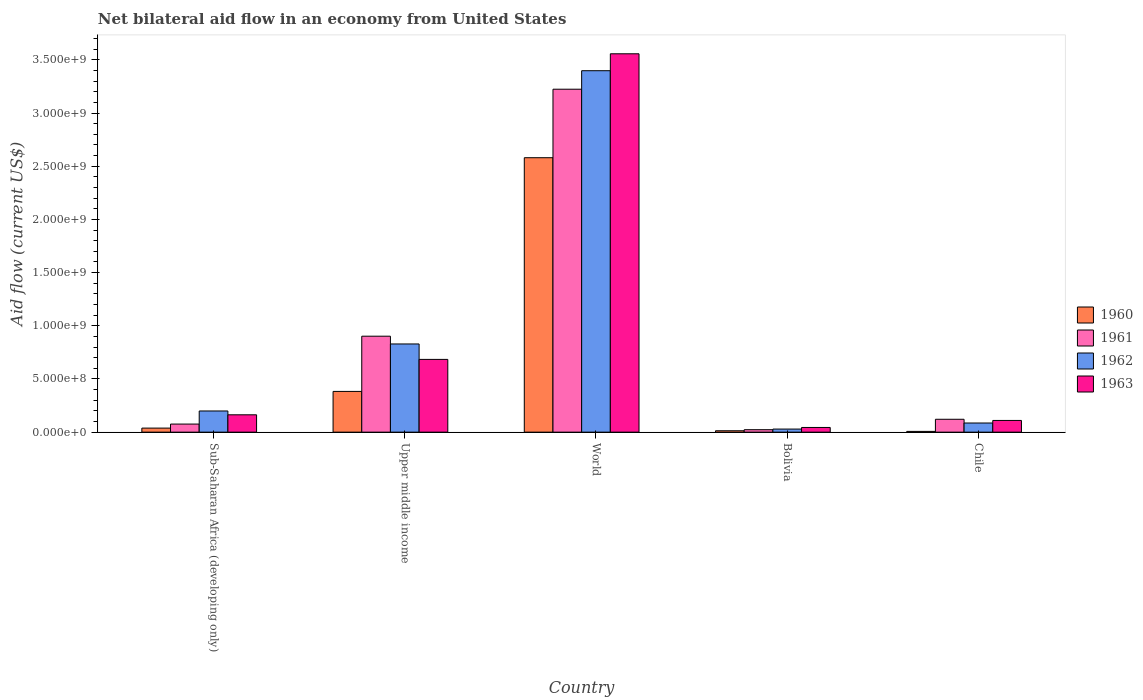How many groups of bars are there?
Keep it short and to the point. 5. Are the number of bars on each tick of the X-axis equal?
Provide a short and direct response. Yes. How many bars are there on the 1st tick from the right?
Provide a short and direct response. 4. What is the label of the 2nd group of bars from the left?
Provide a succinct answer. Upper middle income. What is the net bilateral aid flow in 1961 in Upper middle income?
Provide a short and direct response. 9.02e+08. Across all countries, what is the maximum net bilateral aid flow in 1960?
Provide a succinct answer. 2.58e+09. Across all countries, what is the minimum net bilateral aid flow in 1962?
Provide a succinct answer. 2.90e+07. In which country was the net bilateral aid flow in 1962 maximum?
Offer a very short reply. World. What is the total net bilateral aid flow in 1960 in the graph?
Your response must be concise. 3.02e+09. What is the difference between the net bilateral aid flow in 1963 in Bolivia and that in Upper middle income?
Ensure brevity in your answer.  -6.40e+08. What is the difference between the net bilateral aid flow in 1961 in Bolivia and the net bilateral aid flow in 1962 in Sub-Saharan Africa (developing only)?
Ensure brevity in your answer.  -1.76e+08. What is the average net bilateral aid flow in 1963 per country?
Make the answer very short. 9.12e+08. What is the difference between the net bilateral aid flow of/in 1960 and net bilateral aid flow of/in 1961 in World?
Your answer should be compact. -6.44e+08. What is the ratio of the net bilateral aid flow in 1963 in Sub-Saharan Africa (developing only) to that in Upper middle income?
Make the answer very short. 0.24. Is the net bilateral aid flow in 1961 in Sub-Saharan Africa (developing only) less than that in World?
Give a very brief answer. Yes. What is the difference between the highest and the second highest net bilateral aid flow in 1960?
Provide a short and direct response. 2.54e+09. What is the difference between the highest and the lowest net bilateral aid flow in 1962?
Your response must be concise. 3.37e+09. Is it the case that in every country, the sum of the net bilateral aid flow in 1960 and net bilateral aid flow in 1962 is greater than the sum of net bilateral aid flow in 1961 and net bilateral aid flow in 1963?
Give a very brief answer. No. What does the 4th bar from the left in Chile represents?
Offer a very short reply. 1963. Are all the bars in the graph horizontal?
Provide a short and direct response. No. How many countries are there in the graph?
Ensure brevity in your answer.  5. Are the values on the major ticks of Y-axis written in scientific E-notation?
Ensure brevity in your answer.  Yes. Does the graph contain any zero values?
Provide a succinct answer. No. How many legend labels are there?
Offer a very short reply. 4. What is the title of the graph?
Provide a succinct answer. Net bilateral aid flow in an economy from United States. What is the label or title of the X-axis?
Give a very brief answer. Country. What is the Aid flow (current US$) in 1960 in Sub-Saharan Africa (developing only)?
Ensure brevity in your answer.  3.80e+07. What is the Aid flow (current US$) of 1961 in Sub-Saharan Africa (developing only)?
Keep it short and to the point. 7.60e+07. What is the Aid flow (current US$) of 1962 in Sub-Saharan Africa (developing only)?
Provide a short and direct response. 1.99e+08. What is the Aid flow (current US$) in 1963 in Sub-Saharan Africa (developing only)?
Ensure brevity in your answer.  1.63e+08. What is the Aid flow (current US$) in 1960 in Upper middle income?
Provide a succinct answer. 3.83e+08. What is the Aid flow (current US$) of 1961 in Upper middle income?
Your answer should be compact. 9.02e+08. What is the Aid flow (current US$) in 1962 in Upper middle income?
Ensure brevity in your answer.  8.29e+08. What is the Aid flow (current US$) of 1963 in Upper middle income?
Offer a very short reply. 6.84e+08. What is the Aid flow (current US$) in 1960 in World?
Ensure brevity in your answer.  2.58e+09. What is the Aid flow (current US$) of 1961 in World?
Your answer should be compact. 3.22e+09. What is the Aid flow (current US$) of 1962 in World?
Your response must be concise. 3.40e+09. What is the Aid flow (current US$) of 1963 in World?
Your answer should be compact. 3.56e+09. What is the Aid flow (current US$) of 1960 in Bolivia?
Provide a short and direct response. 1.30e+07. What is the Aid flow (current US$) of 1961 in Bolivia?
Your answer should be very brief. 2.30e+07. What is the Aid flow (current US$) of 1962 in Bolivia?
Provide a succinct answer. 2.90e+07. What is the Aid flow (current US$) in 1963 in Bolivia?
Offer a terse response. 4.40e+07. What is the Aid flow (current US$) in 1961 in Chile?
Your answer should be compact. 1.21e+08. What is the Aid flow (current US$) in 1962 in Chile?
Offer a terse response. 8.60e+07. What is the Aid flow (current US$) of 1963 in Chile?
Offer a very short reply. 1.10e+08. Across all countries, what is the maximum Aid flow (current US$) in 1960?
Provide a short and direct response. 2.58e+09. Across all countries, what is the maximum Aid flow (current US$) of 1961?
Ensure brevity in your answer.  3.22e+09. Across all countries, what is the maximum Aid flow (current US$) in 1962?
Provide a short and direct response. 3.40e+09. Across all countries, what is the maximum Aid flow (current US$) in 1963?
Your answer should be very brief. 3.56e+09. Across all countries, what is the minimum Aid flow (current US$) of 1961?
Keep it short and to the point. 2.30e+07. Across all countries, what is the minimum Aid flow (current US$) in 1962?
Your response must be concise. 2.90e+07. Across all countries, what is the minimum Aid flow (current US$) in 1963?
Keep it short and to the point. 4.40e+07. What is the total Aid flow (current US$) in 1960 in the graph?
Your response must be concise. 3.02e+09. What is the total Aid flow (current US$) in 1961 in the graph?
Your answer should be very brief. 4.35e+09. What is the total Aid flow (current US$) of 1962 in the graph?
Your answer should be very brief. 4.54e+09. What is the total Aid flow (current US$) of 1963 in the graph?
Make the answer very short. 4.56e+09. What is the difference between the Aid flow (current US$) of 1960 in Sub-Saharan Africa (developing only) and that in Upper middle income?
Offer a terse response. -3.45e+08. What is the difference between the Aid flow (current US$) of 1961 in Sub-Saharan Africa (developing only) and that in Upper middle income?
Provide a succinct answer. -8.26e+08. What is the difference between the Aid flow (current US$) of 1962 in Sub-Saharan Africa (developing only) and that in Upper middle income?
Keep it short and to the point. -6.30e+08. What is the difference between the Aid flow (current US$) in 1963 in Sub-Saharan Africa (developing only) and that in Upper middle income?
Make the answer very short. -5.21e+08. What is the difference between the Aid flow (current US$) in 1960 in Sub-Saharan Africa (developing only) and that in World?
Your response must be concise. -2.54e+09. What is the difference between the Aid flow (current US$) in 1961 in Sub-Saharan Africa (developing only) and that in World?
Your response must be concise. -3.15e+09. What is the difference between the Aid flow (current US$) in 1962 in Sub-Saharan Africa (developing only) and that in World?
Offer a very short reply. -3.20e+09. What is the difference between the Aid flow (current US$) of 1963 in Sub-Saharan Africa (developing only) and that in World?
Ensure brevity in your answer.  -3.39e+09. What is the difference between the Aid flow (current US$) of 1960 in Sub-Saharan Africa (developing only) and that in Bolivia?
Provide a succinct answer. 2.50e+07. What is the difference between the Aid flow (current US$) in 1961 in Sub-Saharan Africa (developing only) and that in Bolivia?
Ensure brevity in your answer.  5.30e+07. What is the difference between the Aid flow (current US$) of 1962 in Sub-Saharan Africa (developing only) and that in Bolivia?
Provide a short and direct response. 1.70e+08. What is the difference between the Aid flow (current US$) of 1963 in Sub-Saharan Africa (developing only) and that in Bolivia?
Make the answer very short. 1.19e+08. What is the difference between the Aid flow (current US$) of 1960 in Sub-Saharan Africa (developing only) and that in Chile?
Offer a very short reply. 3.10e+07. What is the difference between the Aid flow (current US$) in 1961 in Sub-Saharan Africa (developing only) and that in Chile?
Give a very brief answer. -4.50e+07. What is the difference between the Aid flow (current US$) of 1962 in Sub-Saharan Africa (developing only) and that in Chile?
Your answer should be compact. 1.13e+08. What is the difference between the Aid flow (current US$) of 1963 in Sub-Saharan Africa (developing only) and that in Chile?
Give a very brief answer. 5.30e+07. What is the difference between the Aid flow (current US$) of 1960 in Upper middle income and that in World?
Give a very brief answer. -2.20e+09. What is the difference between the Aid flow (current US$) in 1961 in Upper middle income and that in World?
Offer a very short reply. -2.32e+09. What is the difference between the Aid flow (current US$) in 1962 in Upper middle income and that in World?
Your response must be concise. -2.57e+09. What is the difference between the Aid flow (current US$) in 1963 in Upper middle income and that in World?
Your response must be concise. -2.87e+09. What is the difference between the Aid flow (current US$) of 1960 in Upper middle income and that in Bolivia?
Offer a terse response. 3.70e+08. What is the difference between the Aid flow (current US$) in 1961 in Upper middle income and that in Bolivia?
Your response must be concise. 8.79e+08. What is the difference between the Aid flow (current US$) in 1962 in Upper middle income and that in Bolivia?
Offer a terse response. 8.00e+08. What is the difference between the Aid flow (current US$) of 1963 in Upper middle income and that in Bolivia?
Your answer should be very brief. 6.40e+08. What is the difference between the Aid flow (current US$) in 1960 in Upper middle income and that in Chile?
Make the answer very short. 3.76e+08. What is the difference between the Aid flow (current US$) of 1961 in Upper middle income and that in Chile?
Provide a succinct answer. 7.81e+08. What is the difference between the Aid flow (current US$) in 1962 in Upper middle income and that in Chile?
Offer a very short reply. 7.43e+08. What is the difference between the Aid flow (current US$) of 1963 in Upper middle income and that in Chile?
Give a very brief answer. 5.74e+08. What is the difference between the Aid flow (current US$) of 1960 in World and that in Bolivia?
Provide a succinct answer. 2.57e+09. What is the difference between the Aid flow (current US$) of 1961 in World and that in Bolivia?
Give a very brief answer. 3.20e+09. What is the difference between the Aid flow (current US$) in 1962 in World and that in Bolivia?
Make the answer very short. 3.37e+09. What is the difference between the Aid flow (current US$) of 1963 in World and that in Bolivia?
Ensure brevity in your answer.  3.51e+09. What is the difference between the Aid flow (current US$) of 1960 in World and that in Chile?
Your answer should be compact. 2.57e+09. What is the difference between the Aid flow (current US$) in 1961 in World and that in Chile?
Keep it short and to the point. 3.10e+09. What is the difference between the Aid flow (current US$) in 1962 in World and that in Chile?
Provide a short and direct response. 3.31e+09. What is the difference between the Aid flow (current US$) of 1963 in World and that in Chile?
Make the answer very short. 3.45e+09. What is the difference between the Aid flow (current US$) of 1961 in Bolivia and that in Chile?
Your response must be concise. -9.80e+07. What is the difference between the Aid flow (current US$) in 1962 in Bolivia and that in Chile?
Ensure brevity in your answer.  -5.70e+07. What is the difference between the Aid flow (current US$) in 1963 in Bolivia and that in Chile?
Offer a very short reply. -6.60e+07. What is the difference between the Aid flow (current US$) in 1960 in Sub-Saharan Africa (developing only) and the Aid flow (current US$) in 1961 in Upper middle income?
Your response must be concise. -8.64e+08. What is the difference between the Aid flow (current US$) of 1960 in Sub-Saharan Africa (developing only) and the Aid flow (current US$) of 1962 in Upper middle income?
Your response must be concise. -7.91e+08. What is the difference between the Aid flow (current US$) in 1960 in Sub-Saharan Africa (developing only) and the Aid flow (current US$) in 1963 in Upper middle income?
Your answer should be very brief. -6.46e+08. What is the difference between the Aid flow (current US$) in 1961 in Sub-Saharan Africa (developing only) and the Aid flow (current US$) in 1962 in Upper middle income?
Your answer should be compact. -7.53e+08. What is the difference between the Aid flow (current US$) of 1961 in Sub-Saharan Africa (developing only) and the Aid flow (current US$) of 1963 in Upper middle income?
Offer a very short reply. -6.08e+08. What is the difference between the Aid flow (current US$) of 1962 in Sub-Saharan Africa (developing only) and the Aid flow (current US$) of 1963 in Upper middle income?
Offer a terse response. -4.85e+08. What is the difference between the Aid flow (current US$) of 1960 in Sub-Saharan Africa (developing only) and the Aid flow (current US$) of 1961 in World?
Keep it short and to the point. -3.19e+09. What is the difference between the Aid flow (current US$) of 1960 in Sub-Saharan Africa (developing only) and the Aid flow (current US$) of 1962 in World?
Your answer should be compact. -3.36e+09. What is the difference between the Aid flow (current US$) in 1960 in Sub-Saharan Africa (developing only) and the Aid flow (current US$) in 1963 in World?
Your answer should be very brief. -3.52e+09. What is the difference between the Aid flow (current US$) in 1961 in Sub-Saharan Africa (developing only) and the Aid flow (current US$) in 1962 in World?
Provide a short and direct response. -3.32e+09. What is the difference between the Aid flow (current US$) of 1961 in Sub-Saharan Africa (developing only) and the Aid flow (current US$) of 1963 in World?
Offer a terse response. -3.48e+09. What is the difference between the Aid flow (current US$) in 1962 in Sub-Saharan Africa (developing only) and the Aid flow (current US$) in 1963 in World?
Ensure brevity in your answer.  -3.36e+09. What is the difference between the Aid flow (current US$) of 1960 in Sub-Saharan Africa (developing only) and the Aid flow (current US$) of 1961 in Bolivia?
Your answer should be compact. 1.50e+07. What is the difference between the Aid flow (current US$) in 1960 in Sub-Saharan Africa (developing only) and the Aid flow (current US$) in 1962 in Bolivia?
Your answer should be compact. 9.00e+06. What is the difference between the Aid flow (current US$) in 1960 in Sub-Saharan Africa (developing only) and the Aid flow (current US$) in 1963 in Bolivia?
Give a very brief answer. -6.00e+06. What is the difference between the Aid flow (current US$) of 1961 in Sub-Saharan Africa (developing only) and the Aid flow (current US$) of 1962 in Bolivia?
Ensure brevity in your answer.  4.70e+07. What is the difference between the Aid flow (current US$) in 1961 in Sub-Saharan Africa (developing only) and the Aid flow (current US$) in 1963 in Bolivia?
Your response must be concise. 3.20e+07. What is the difference between the Aid flow (current US$) in 1962 in Sub-Saharan Africa (developing only) and the Aid flow (current US$) in 1963 in Bolivia?
Your answer should be compact. 1.55e+08. What is the difference between the Aid flow (current US$) in 1960 in Sub-Saharan Africa (developing only) and the Aid flow (current US$) in 1961 in Chile?
Provide a short and direct response. -8.30e+07. What is the difference between the Aid flow (current US$) of 1960 in Sub-Saharan Africa (developing only) and the Aid flow (current US$) of 1962 in Chile?
Your answer should be compact. -4.80e+07. What is the difference between the Aid flow (current US$) of 1960 in Sub-Saharan Africa (developing only) and the Aid flow (current US$) of 1963 in Chile?
Ensure brevity in your answer.  -7.20e+07. What is the difference between the Aid flow (current US$) in 1961 in Sub-Saharan Africa (developing only) and the Aid flow (current US$) in 1962 in Chile?
Give a very brief answer. -1.00e+07. What is the difference between the Aid flow (current US$) in 1961 in Sub-Saharan Africa (developing only) and the Aid flow (current US$) in 1963 in Chile?
Provide a short and direct response. -3.40e+07. What is the difference between the Aid flow (current US$) of 1962 in Sub-Saharan Africa (developing only) and the Aid flow (current US$) of 1963 in Chile?
Your answer should be compact. 8.90e+07. What is the difference between the Aid flow (current US$) in 1960 in Upper middle income and the Aid flow (current US$) in 1961 in World?
Provide a succinct answer. -2.84e+09. What is the difference between the Aid flow (current US$) of 1960 in Upper middle income and the Aid flow (current US$) of 1962 in World?
Ensure brevity in your answer.  -3.02e+09. What is the difference between the Aid flow (current US$) of 1960 in Upper middle income and the Aid flow (current US$) of 1963 in World?
Ensure brevity in your answer.  -3.17e+09. What is the difference between the Aid flow (current US$) in 1961 in Upper middle income and the Aid flow (current US$) in 1962 in World?
Provide a succinct answer. -2.50e+09. What is the difference between the Aid flow (current US$) of 1961 in Upper middle income and the Aid flow (current US$) of 1963 in World?
Your answer should be very brief. -2.66e+09. What is the difference between the Aid flow (current US$) in 1962 in Upper middle income and the Aid flow (current US$) in 1963 in World?
Offer a terse response. -2.73e+09. What is the difference between the Aid flow (current US$) in 1960 in Upper middle income and the Aid flow (current US$) in 1961 in Bolivia?
Your answer should be compact. 3.60e+08. What is the difference between the Aid flow (current US$) of 1960 in Upper middle income and the Aid flow (current US$) of 1962 in Bolivia?
Offer a terse response. 3.54e+08. What is the difference between the Aid flow (current US$) of 1960 in Upper middle income and the Aid flow (current US$) of 1963 in Bolivia?
Provide a short and direct response. 3.39e+08. What is the difference between the Aid flow (current US$) of 1961 in Upper middle income and the Aid flow (current US$) of 1962 in Bolivia?
Your response must be concise. 8.73e+08. What is the difference between the Aid flow (current US$) in 1961 in Upper middle income and the Aid flow (current US$) in 1963 in Bolivia?
Provide a short and direct response. 8.58e+08. What is the difference between the Aid flow (current US$) of 1962 in Upper middle income and the Aid flow (current US$) of 1963 in Bolivia?
Provide a succinct answer. 7.85e+08. What is the difference between the Aid flow (current US$) in 1960 in Upper middle income and the Aid flow (current US$) in 1961 in Chile?
Keep it short and to the point. 2.62e+08. What is the difference between the Aid flow (current US$) of 1960 in Upper middle income and the Aid flow (current US$) of 1962 in Chile?
Your response must be concise. 2.97e+08. What is the difference between the Aid flow (current US$) of 1960 in Upper middle income and the Aid flow (current US$) of 1963 in Chile?
Provide a succinct answer. 2.73e+08. What is the difference between the Aid flow (current US$) in 1961 in Upper middle income and the Aid flow (current US$) in 1962 in Chile?
Offer a terse response. 8.16e+08. What is the difference between the Aid flow (current US$) of 1961 in Upper middle income and the Aid flow (current US$) of 1963 in Chile?
Provide a succinct answer. 7.92e+08. What is the difference between the Aid flow (current US$) of 1962 in Upper middle income and the Aid flow (current US$) of 1963 in Chile?
Your response must be concise. 7.19e+08. What is the difference between the Aid flow (current US$) in 1960 in World and the Aid flow (current US$) in 1961 in Bolivia?
Your answer should be very brief. 2.56e+09. What is the difference between the Aid flow (current US$) in 1960 in World and the Aid flow (current US$) in 1962 in Bolivia?
Keep it short and to the point. 2.55e+09. What is the difference between the Aid flow (current US$) of 1960 in World and the Aid flow (current US$) of 1963 in Bolivia?
Keep it short and to the point. 2.54e+09. What is the difference between the Aid flow (current US$) in 1961 in World and the Aid flow (current US$) in 1962 in Bolivia?
Provide a short and direct response. 3.20e+09. What is the difference between the Aid flow (current US$) in 1961 in World and the Aid flow (current US$) in 1963 in Bolivia?
Give a very brief answer. 3.18e+09. What is the difference between the Aid flow (current US$) of 1962 in World and the Aid flow (current US$) of 1963 in Bolivia?
Your answer should be very brief. 3.35e+09. What is the difference between the Aid flow (current US$) of 1960 in World and the Aid flow (current US$) of 1961 in Chile?
Your response must be concise. 2.46e+09. What is the difference between the Aid flow (current US$) in 1960 in World and the Aid flow (current US$) in 1962 in Chile?
Your response must be concise. 2.49e+09. What is the difference between the Aid flow (current US$) in 1960 in World and the Aid flow (current US$) in 1963 in Chile?
Your answer should be very brief. 2.47e+09. What is the difference between the Aid flow (current US$) in 1961 in World and the Aid flow (current US$) in 1962 in Chile?
Your response must be concise. 3.14e+09. What is the difference between the Aid flow (current US$) of 1961 in World and the Aid flow (current US$) of 1963 in Chile?
Make the answer very short. 3.11e+09. What is the difference between the Aid flow (current US$) in 1962 in World and the Aid flow (current US$) in 1963 in Chile?
Your response must be concise. 3.29e+09. What is the difference between the Aid flow (current US$) in 1960 in Bolivia and the Aid flow (current US$) in 1961 in Chile?
Offer a very short reply. -1.08e+08. What is the difference between the Aid flow (current US$) of 1960 in Bolivia and the Aid flow (current US$) of 1962 in Chile?
Give a very brief answer. -7.30e+07. What is the difference between the Aid flow (current US$) in 1960 in Bolivia and the Aid flow (current US$) in 1963 in Chile?
Provide a short and direct response. -9.70e+07. What is the difference between the Aid flow (current US$) of 1961 in Bolivia and the Aid flow (current US$) of 1962 in Chile?
Offer a very short reply. -6.30e+07. What is the difference between the Aid flow (current US$) in 1961 in Bolivia and the Aid flow (current US$) in 1963 in Chile?
Your answer should be compact. -8.70e+07. What is the difference between the Aid flow (current US$) in 1962 in Bolivia and the Aid flow (current US$) in 1963 in Chile?
Your answer should be very brief. -8.10e+07. What is the average Aid flow (current US$) in 1960 per country?
Ensure brevity in your answer.  6.04e+08. What is the average Aid flow (current US$) in 1961 per country?
Ensure brevity in your answer.  8.69e+08. What is the average Aid flow (current US$) of 1962 per country?
Your answer should be very brief. 9.08e+08. What is the average Aid flow (current US$) of 1963 per country?
Keep it short and to the point. 9.12e+08. What is the difference between the Aid flow (current US$) of 1960 and Aid flow (current US$) of 1961 in Sub-Saharan Africa (developing only)?
Ensure brevity in your answer.  -3.80e+07. What is the difference between the Aid flow (current US$) of 1960 and Aid flow (current US$) of 1962 in Sub-Saharan Africa (developing only)?
Make the answer very short. -1.61e+08. What is the difference between the Aid flow (current US$) in 1960 and Aid flow (current US$) in 1963 in Sub-Saharan Africa (developing only)?
Provide a short and direct response. -1.25e+08. What is the difference between the Aid flow (current US$) in 1961 and Aid flow (current US$) in 1962 in Sub-Saharan Africa (developing only)?
Offer a terse response. -1.23e+08. What is the difference between the Aid flow (current US$) in 1961 and Aid flow (current US$) in 1963 in Sub-Saharan Africa (developing only)?
Your answer should be very brief. -8.70e+07. What is the difference between the Aid flow (current US$) in 1962 and Aid flow (current US$) in 1963 in Sub-Saharan Africa (developing only)?
Your answer should be very brief. 3.60e+07. What is the difference between the Aid flow (current US$) of 1960 and Aid flow (current US$) of 1961 in Upper middle income?
Ensure brevity in your answer.  -5.19e+08. What is the difference between the Aid flow (current US$) of 1960 and Aid flow (current US$) of 1962 in Upper middle income?
Ensure brevity in your answer.  -4.46e+08. What is the difference between the Aid flow (current US$) in 1960 and Aid flow (current US$) in 1963 in Upper middle income?
Provide a succinct answer. -3.01e+08. What is the difference between the Aid flow (current US$) of 1961 and Aid flow (current US$) of 1962 in Upper middle income?
Ensure brevity in your answer.  7.30e+07. What is the difference between the Aid flow (current US$) in 1961 and Aid flow (current US$) in 1963 in Upper middle income?
Give a very brief answer. 2.18e+08. What is the difference between the Aid flow (current US$) in 1962 and Aid flow (current US$) in 1963 in Upper middle income?
Offer a terse response. 1.45e+08. What is the difference between the Aid flow (current US$) of 1960 and Aid flow (current US$) of 1961 in World?
Ensure brevity in your answer.  -6.44e+08. What is the difference between the Aid flow (current US$) of 1960 and Aid flow (current US$) of 1962 in World?
Make the answer very short. -8.18e+08. What is the difference between the Aid flow (current US$) of 1960 and Aid flow (current US$) of 1963 in World?
Make the answer very short. -9.77e+08. What is the difference between the Aid flow (current US$) in 1961 and Aid flow (current US$) in 1962 in World?
Your answer should be compact. -1.74e+08. What is the difference between the Aid flow (current US$) in 1961 and Aid flow (current US$) in 1963 in World?
Your answer should be compact. -3.33e+08. What is the difference between the Aid flow (current US$) of 1962 and Aid flow (current US$) of 1963 in World?
Provide a succinct answer. -1.59e+08. What is the difference between the Aid flow (current US$) in 1960 and Aid flow (current US$) in 1961 in Bolivia?
Offer a terse response. -1.00e+07. What is the difference between the Aid flow (current US$) of 1960 and Aid flow (current US$) of 1962 in Bolivia?
Your response must be concise. -1.60e+07. What is the difference between the Aid flow (current US$) of 1960 and Aid flow (current US$) of 1963 in Bolivia?
Provide a succinct answer. -3.10e+07. What is the difference between the Aid flow (current US$) in 1961 and Aid flow (current US$) in 1962 in Bolivia?
Offer a very short reply. -6.00e+06. What is the difference between the Aid flow (current US$) in 1961 and Aid flow (current US$) in 1963 in Bolivia?
Ensure brevity in your answer.  -2.10e+07. What is the difference between the Aid flow (current US$) in 1962 and Aid flow (current US$) in 1963 in Bolivia?
Your answer should be very brief. -1.50e+07. What is the difference between the Aid flow (current US$) in 1960 and Aid flow (current US$) in 1961 in Chile?
Make the answer very short. -1.14e+08. What is the difference between the Aid flow (current US$) of 1960 and Aid flow (current US$) of 1962 in Chile?
Provide a short and direct response. -7.90e+07. What is the difference between the Aid flow (current US$) of 1960 and Aid flow (current US$) of 1963 in Chile?
Offer a very short reply. -1.03e+08. What is the difference between the Aid flow (current US$) of 1961 and Aid flow (current US$) of 1962 in Chile?
Keep it short and to the point. 3.50e+07. What is the difference between the Aid flow (current US$) in 1961 and Aid flow (current US$) in 1963 in Chile?
Keep it short and to the point. 1.10e+07. What is the difference between the Aid flow (current US$) of 1962 and Aid flow (current US$) of 1963 in Chile?
Provide a short and direct response. -2.40e+07. What is the ratio of the Aid flow (current US$) of 1960 in Sub-Saharan Africa (developing only) to that in Upper middle income?
Provide a short and direct response. 0.1. What is the ratio of the Aid flow (current US$) in 1961 in Sub-Saharan Africa (developing only) to that in Upper middle income?
Make the answer very short. 0.08. What is the ratio of the Aid flow (current US$) of 1962 in Sub-Saharan Africa (developing only) to that in Upper middle income?
Offer a very short reply. 0.24. What is the ratio of the Aid flow (current US$) of 1963 in Sub-Saharan Africa (developing only) to that in Upper middle income?
Your answer should be very brief. 0.24. What is the ratio of the Aid flow (current US$) in 1960 in Sub-Saharan Africa (developing only) to that in World?
Give a very brief answer. 0.01. What is the ratio of the Aid flow (current US$) of 1961 in Sub-Saharan Africa (developing only) to that in World?
Your answer should be compact. 0.02. What is the ratio of the Aid flow (current US$) of 1962 in Sub-Saharan Africa (developing only) to that in World?
Offer a terse response. 0.06. What is the ratio of the Aid flow (current US$) in 1963 in Sub-Saharan Africa (developing only) to that in World?
Provide a short and direct response. 0.05. What is the ratio of the Aid flow (current US$) of 1960 in Sub-Saharan Africa (developing only) to that in Bolivia?
Make the answer very short. 2.92. What is the ratio of the Aid flow (current US$) in 1961 in Sub-Saharan Africa (developing only) to that in Bolivia?
Offer a very short reply. 3.3. What is the ratio of the Aid flow (current US$) of 1962 in Sub-Saharan Africa (developing only) to that in Bolivia?
Make the answer very short. 6.86. What is the ratio of the Aid flow (current US$) of 1963 in Sub-Saharan Africa (developing only) to that in Bolivia?
Ensure brevity in your answer.  3.7. What is the ratio of the Aid flow (current US$) in 1960 in Sub-Saharan Africa (developing only) to that in Chile?
Your answer should be compact. 5.43. What is the ratio of the Aid flow (current US$) in 1961 in Sub-Saharan Africa (developing only) to that in Chile?
Offer a very short reply. 0.63. What is the ratio of the Aid flow (current US$) of 1962 in Sub-Saharan Africa (developing only) to that in Chile?
Provide a succinct answer. 2.31. What is the ratio of the Aid flow (current US$) in 1963 in Sub-Saharan Africa (developing only) to that in Chile?
Provide a short and direct response. 1.48. What is the ratio of the Aid flow (current US$) in 1960 in Upper middle income to that in World?
Ensure brevity in your answer.  0.15. What is the ratio of the Aid flow (current US$) in 1961 in Upper middle income to that in World?
Offer a terse response. 0.28. What is the ratio of the Aid flow (current US$) of 1962 in Upper middle income to that in World?
Keep it short and to the point. 0.24. What is the ratio of the Aid flow (current US$) of 1963 in Upper middle income to that in World?
Keep it short and to the point. 0.19. What is the ratio of the Aid flow (current US$) of 1960 in Upper middle income to that in Bolivia?
Offer a terse response. 29.46. What is the ratio of the Aid flow (current US$) of 1961 in Upper middle income to that in Bolivia?
Ensure brevity in your answer.  39.22. What is the ratio of the Aid flow (current US$) in 1962 in Upper middle income to that in Bolivia?
Your answer should be very brief. 28.59. What is the ratio of the Aid flow (current US$) of 1963 in Upper middle income to that in Bolivia?
Your answer should be compact. 15.55. What is the ratio of the Aid flow (current US$) in 1960 in Upper middle income to that in Chile?
Keep it short and to the point. 54.71. What is the ratio of the Aid flow (current US$) of 1961 in Upper middle income to that in Chile?
Make the answer very short. 7.45. What is the ratio of the Aid flow (current US$) in 1962 in Upper middle income to that in Chile?
Give a very brief answer. 9.64. What is the ratio of the Aid flow (current US$) in 1963 in Upper middle income to that in Chile?
Keep it short and to the point. 6.22. What is the ratio of the Aid flow (current US$) in 1960 in World to that in Bolivia?
Give a very brief answer. 198.46. What is the ratio of the Aid flow (current US$) in 1961 in World to that in Bolivia?
Your answer should be very brief. 140.17. What is the ratio of the Aid flow (current US$) of 1962 in World to that in Bolivia?
Your answer should be compact. 117.17. What is the ratio of the Aid flow (current US$) in 1963 in World to that in Bolivia?
Keep it short and to the point. 80.84. What is the ratio of the Aid flow (current US$) in 1960 in World to that in Chile?
Offer a terse response. 368.57. What is the ratio of the Aid flow (current US$) in 1961 in World to that in Chile?
Your answer should be very brief. 26.64. What is the ratio of the Aid flow (current US$) of 1962 in World to that in Chile?
Give a very brief answer. 39.51. What is the ratio of the Aid flow (current US$) of 1963 in World to that in Chile?
Your answer should be very brief. 32.34. What is the ratio of the Aid flow (current US$) of 1960 in Bolivia to that in Chile?
Keep it short and to the point. 1.86. What is the ratio of the Aid flow (current US$) in 1961 in Bolivia to that in Chile?
Your answer should be compact. 0.19. What is the ratio of the Aid flow (current US$) of 1962 in Bolivia to that in Chile?
Offer a terse response. 0.34. What is the ratio of the Aid flow (current US$) of 1963 in Bolivia to that in Chile?
Your response must be concise. 0.4. What is the difference between the highest and the second highest Aid flow (current US$) of 1960?
Make the answer very short. 2.20e+09. What is the difference between the highest and the second highest Aid flow (current US$) in 1961?
Offer a very short reply. 2.32e+09. What is the difference between the highest and the second highest Aid flow (current US$) in 1962?
Provide a succinct answer. 2.57e+09. What is the difference between the highest and the second highest Aid flow (current US$) of 1963?
Offer a very short reply. 2.87e+09. What is the difference between the highest and the lowest Aid flow (current US$) of 1960?
Provide a short and direct response. 2.57e+09. What is the difference between the highest and the lowest Aid flow (current US$) of 1961?
Give a very brief answer. 3.20e+09. What is the difference between the highest and the lowest Aid flow (current US$) in 1962?
Make the answer very short. 3.37e+09. What is the difference between the highest and the lowest Aid flow (current US$) in 1963?
Your response must be concise. 3.51e+09. 